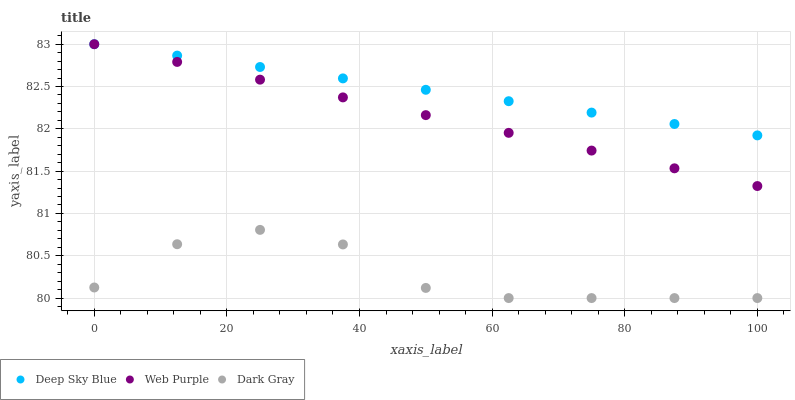Does Dark Gray have the minimum area under the curve?
Answer yes or no. Yes. Does Deep Sky Blue have the maximum area under the curve?
Answer yes or no. Yes. Does Web Purple have the minimum area under the curve?
Answer yes or no. No. Does Web Purple have the maximum area under the curve?
Answer yes or no. No. Is Web Purple the smoothest?
Answer yes or no. Yes. Is Dark Gray the roughest?
Answer yes or no. Yes. Is Deep Sky Blue the smoothest?
Answer yes or no. No. Is Deep Sky Blue the roughest?
Answer yes or no. No. Does Dark Gray have the lowest value?
Answer yes or no. Yes. Does Web Purple have the lowest value?
Answer yes or no. No. Does Deep Sky Blue have the highest value?
Answer yes or no. Yes. Is Dark Gray less than Web Purple?
Answer yes or no. Yes. Is Web Purple greater than Dark Gray?
Answer yes or no. Yes. Does Deep Sky Blue intersect Web Purple?
Answer yes or no. Yes. Is Deep Sky Blue less than Web Purple?
Answer yes or no. No. Is Deep Sky Blue greater than Web Purple?
Answer yes or no. No. Does Dark Gray intersect Web Purple?
Answer yes or no. No. 